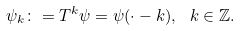<formula> <loc_0><loc_0><loc_500><loc_500>\psi _ { k } \colon = T ^ { k } \psi = \psi ( \cdot - k ) , \text { } k \in \mathbb { Z } .</formula> 